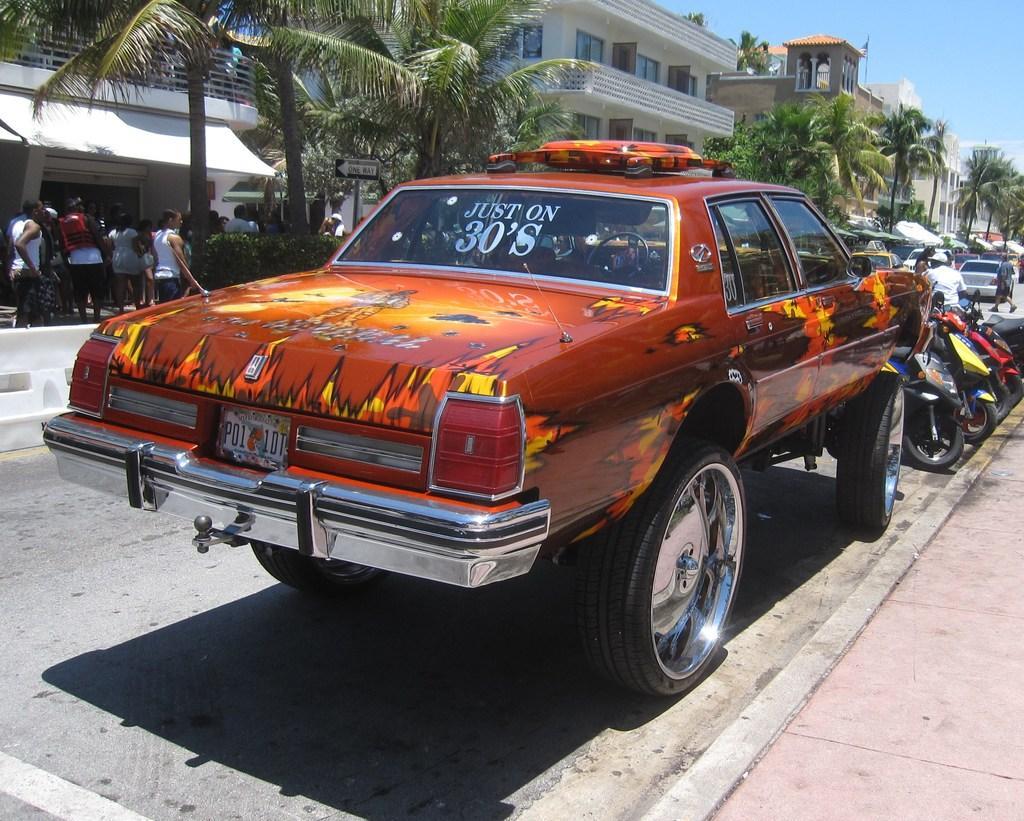In one or two sentences, can you explain what this image depicts? In this picture I can see the cars, bikes and other vehicles on the road. On the left I can see the group of persons who are standing near to the plants, trees and building. In the background I can see many trees, buildings and street light. In the top right corner I can see the sky. 